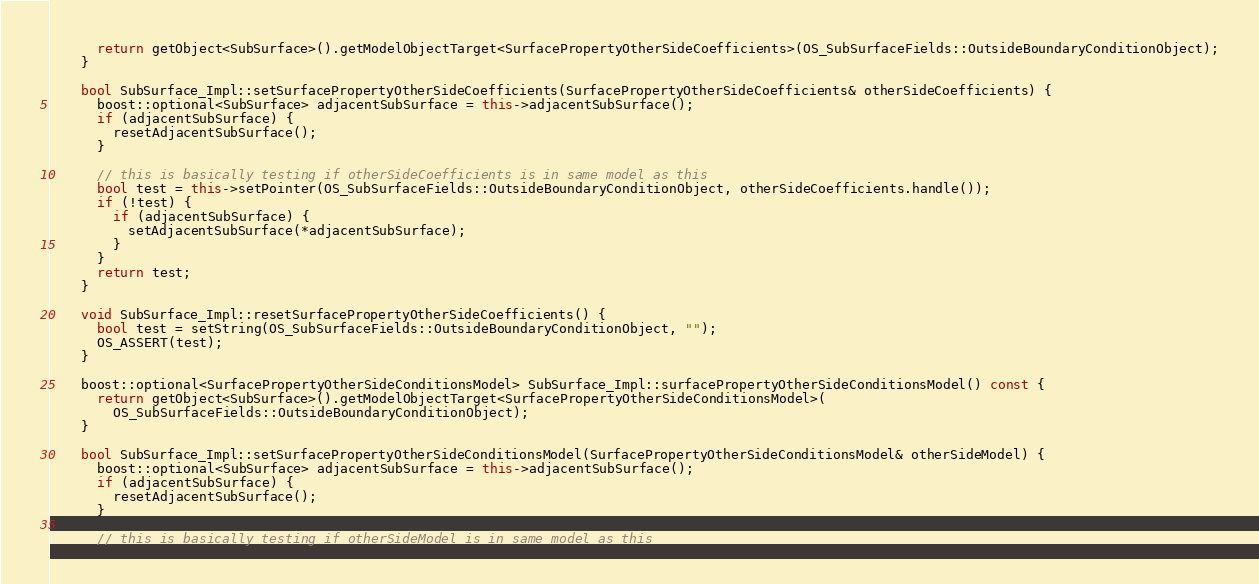Convert code to text. <code><loc_0><loc_0><loc_500><loc_500><_C++_>      return getObject<SubSurface>().getModelObjectTarget<SurfacePropertyOtherSideCoefficients>(OS_SubSurfaceFields::OutsideBoundaryConditionObject);
    }

    bool SubSurface_Impl::setSurfacePropertyOtherSideCoefficients(SurfacePropertyOtherSideCoefficients& otherSideCoefficients) {
      boost::optional<SubSurface> adjacentSubSurface = this->adjacentSubSurface();
      if (adjacentSubSurface) {
        resetAdjacentSubSurface();
      }

      // this is basically testing if otherSideCoefficients is in same model as this
      bool test = this->setPointer(OS_SubSurfaceFields::OutsideBoundaryConditionObject, otherSideCoefficients.handle());
      if (!test) {
        if (adjacentSubSurface) {
          setAdjacentSubSurface(*adjacentSubSurface);
        }
      }
      return test;
    }

    void SubSurface_Impl::resetSurfacePropertyOtherSideCoefficients() {
      bool test = setString(OS_SubSurfaceFields::OutsideBoundaryConditionObject, "");
      OS_ASSERT(test);
    }

    boost::optional<SurfacePropertyOtherSideConditionsModel> SubSurface_Impl::surfacePropertyOtherSideConditionsModel() const {
      return getObject<SubSurface>().getModelObjectTarget<SurfacePropertyOtherSideConditionsModel>(
        OS_SubSurfaceFields::OutsideBoundaryConditionObject);
    }

    bool SubSurface_Impl::setSurfacePropertyOtherSideConditionsModel(SurfacePropertyOtherSideConditionsModel& otherSideModel) {
      boost::optional<SubSurface> adjacentSubSurface = this->adjacentSubSurface();
      if (adjacentSubSurface) {
        resetAdjacentSubSurface();
      }

      // this is basically testing if otherSideModel is in same model as this</code> 